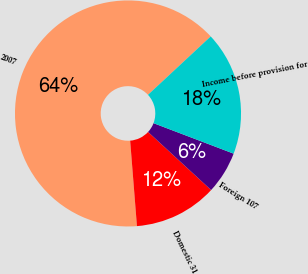Convert chart. <chart><loc_0><loc_0><loc_500><loc_500><pie_chart><fcel>2007<fcel>Domestic 31<fcel>Foreign 107<fcel>Income before provision for<nl><fcel>64.33%<fcel>11.89%<fcel>6.06%<fcel>17.72%<nl></chart> 